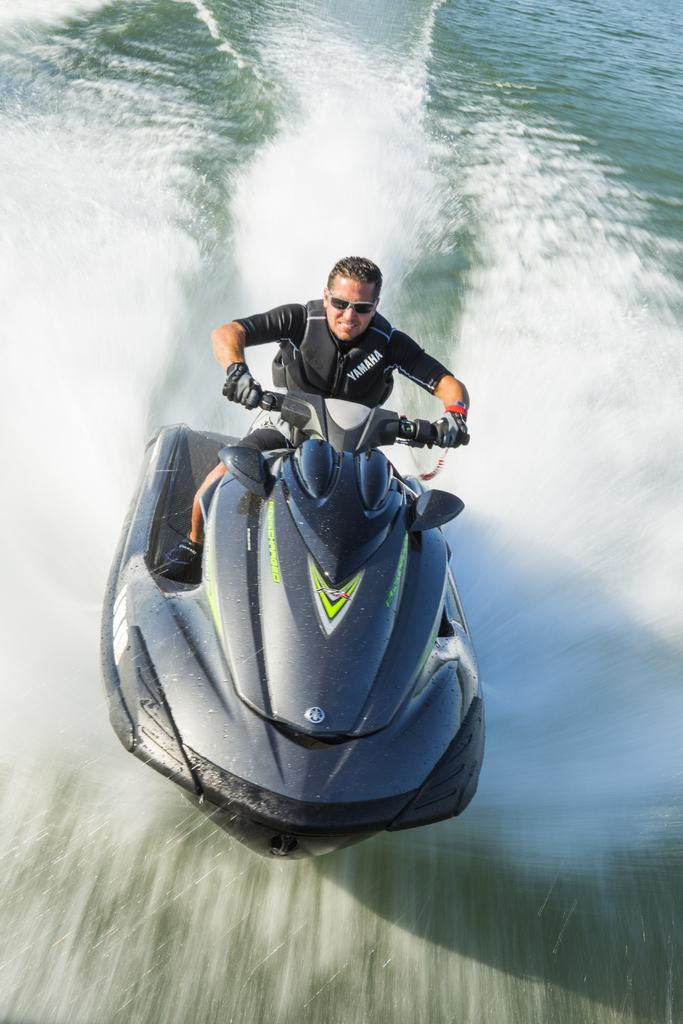What is the man in the image doing? The man is sitting and riding a boat in the image. What is the position of the boat in relation to the water? The boat is above the water in the image. What accessories is the man wearing while riding the boat? The man is wearing gloves and glasses in the image. What type of cream can be seen being used to polish the copper in the image? There is no cream or copper present in the image; it features a man sitting and riding a boat. 